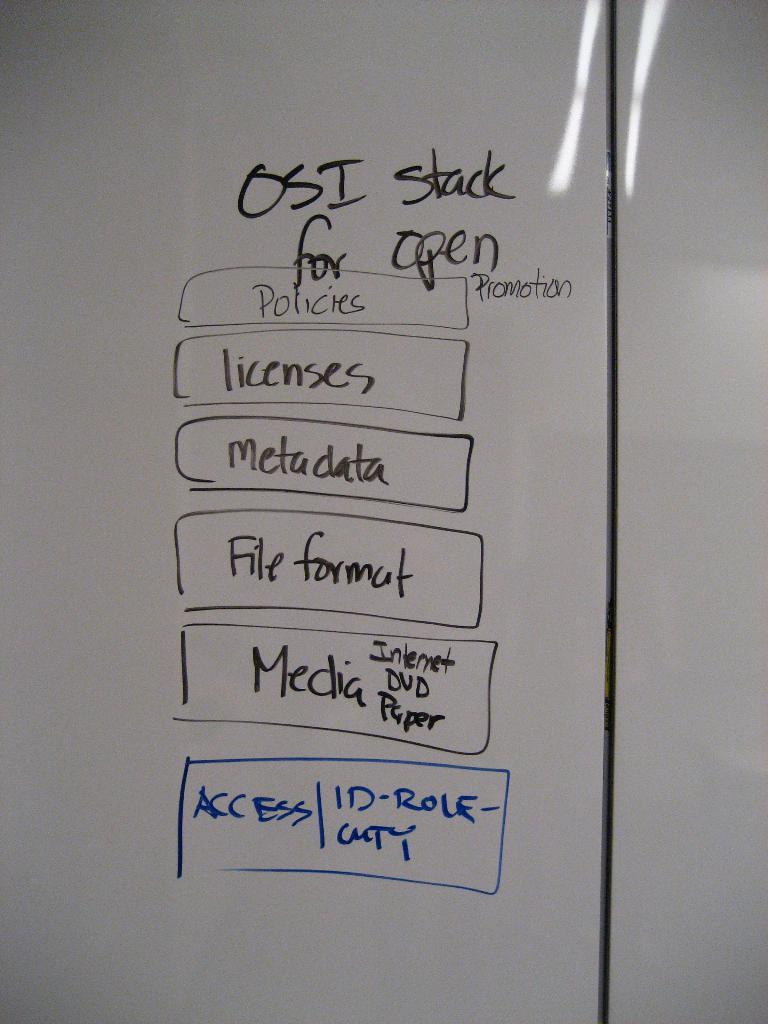What information is in the second box?
Your answer should be compact. Licenses. 